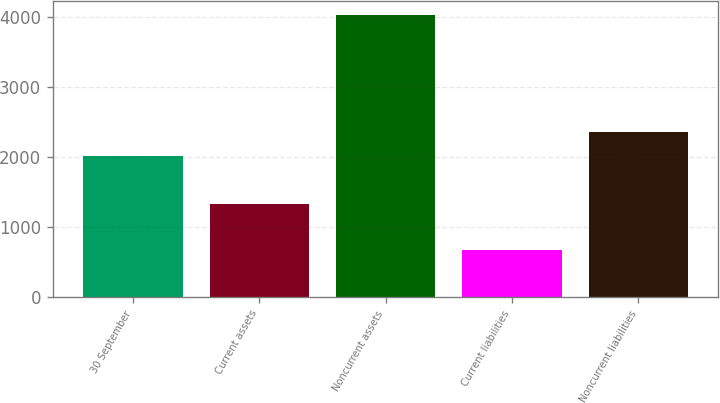<chart> <loc_0><loc_0><loc_500><loc_500><bar_chart><fcel>30 September<fcel>Current assets<fcel>Noncurrent assets<fcel>Current liabilities<fcel>Noncurrent liabilities<nl><fcel>2017<fcel>1333.2<fcel>4026.9<fcel>666.8<fcel>2353.01<nl></chart> 